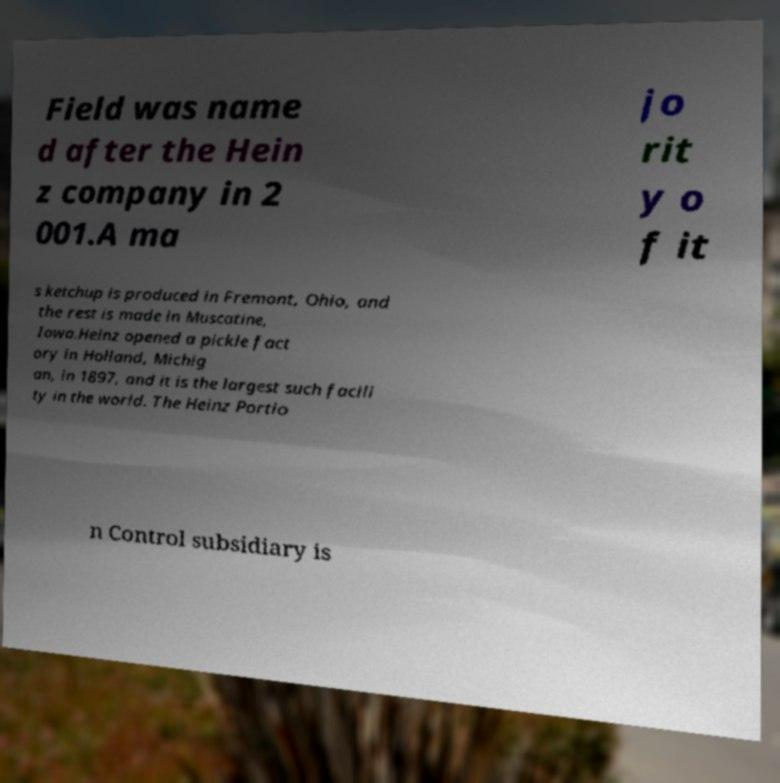Could you assist in decoding the text presented in this image and type it out clearly? Field was name d after the Hein z company in 2 001.A ma jo rit y o f it s ketchup is produced in Fremont, Ohio, and the rest is made in Muscatine, Iowa.Heinz opened a pickle fact ory in Holland, Michig an, in 1897, and it is the largest such facili ty in the world. The Heinz Portio n Control subsidiary is 